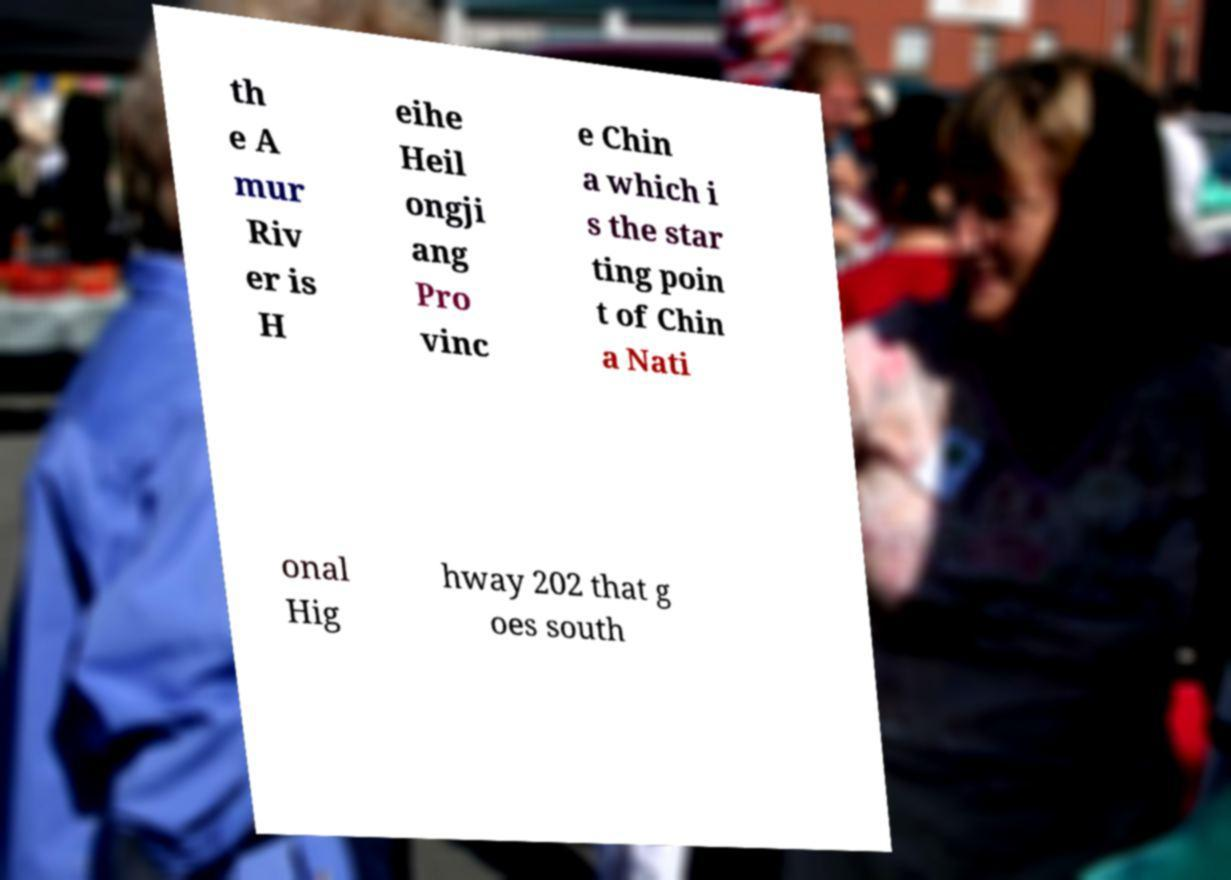Can you accurately transcribe the text from the provided image for me? th e A mur Riv er is H eihe Heil ongji ang Pro vinc e Chin a which i s the star ting poin t of Chin a Nati onal Hig hway 202 that g oes south 